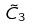Convert formula to latex. <formula><loc_0><loc_0><loc_500><loc_500>\tilde { C } _ { 3 }</formula> 